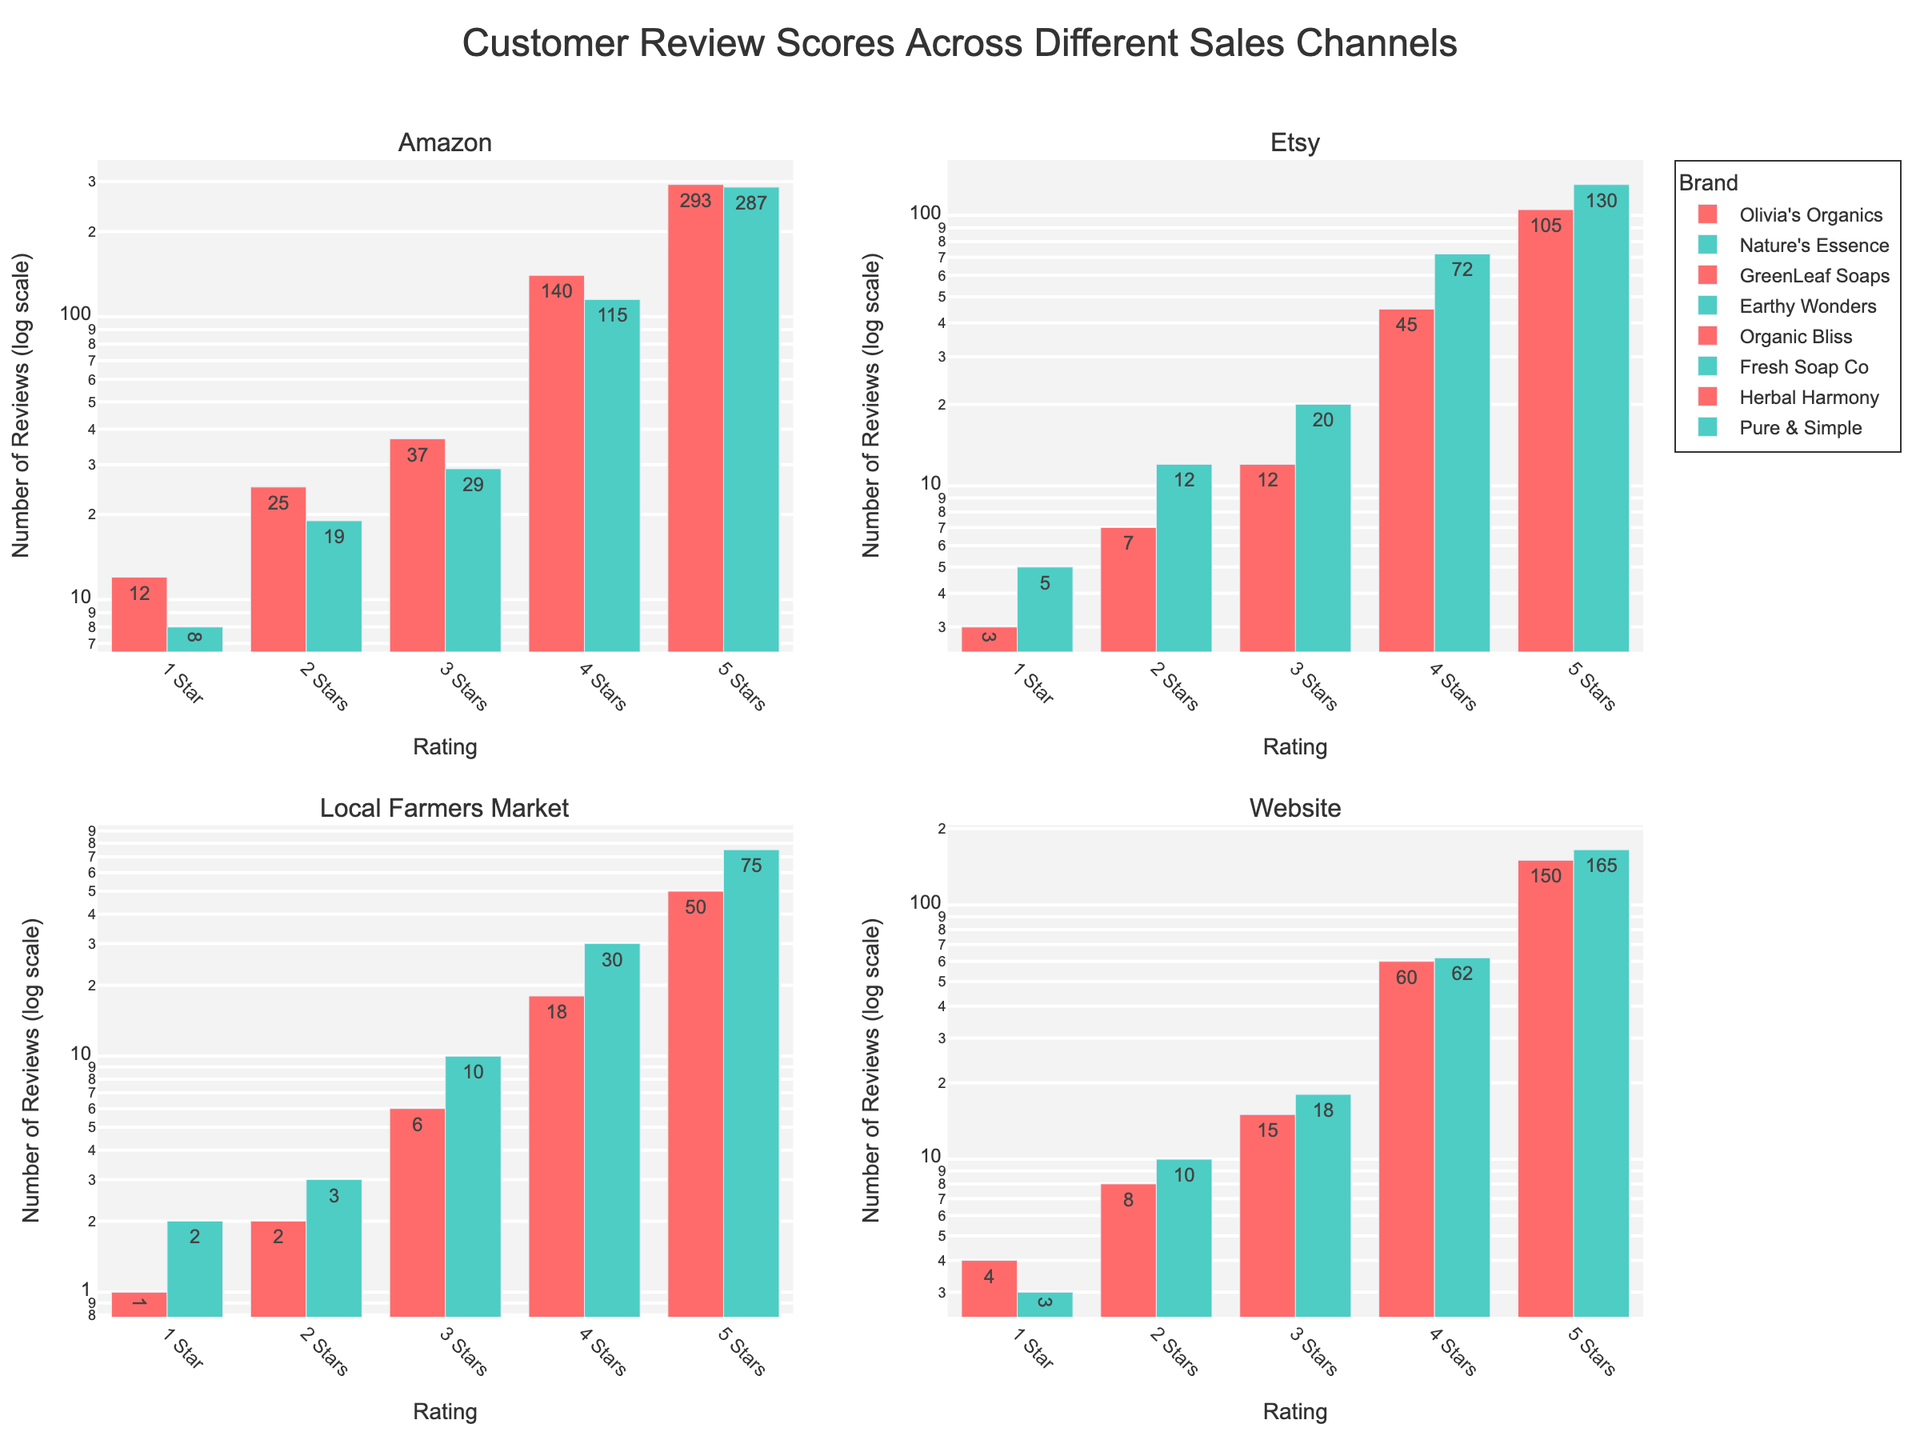How many brands are displayed in each subplot? Count the number of different brands in each subplot for Amazon, Etsy, Farmers Market, and Website.
Answer: 2 brands each Which sales channel received the highest number of 5-star reviews for any brand? Compare the lengths of the bars representing 5-star reviews across all brands in each sales channel. The highest bar is for Olivia's Organics on Amazon.
Answer: Amazon How do the total reviews for GreenLeaf Soaps and Earthy Wonders on Etsy compare? Sum the reviews for each star rating for both brands and compare: GreenLeaf Soaps = 172; Earthy Wonders = 239.
Answer: Earthy Wonders has more What is the total number of 2-star reviews for brands sold at the local farmers market? Add the 2-star reviews for Organic Bliss and Fresh Soap Co: 2 + 3.
Answer: 5 Which brand on the website has a higher proportion of 5-star reviews? Calculate the proportion of 5-star reviews by dividing the 5-star count by the total reviews for each brand: Herbal Harmony = 150/237, Pure & Simple = 165/258.
Answer: Pure & Simple How many more 5-star reviews does Olivia's Organics on Amazon have compared to Fresh Soap Co at the farmers market? Subtract the 5-star reviews for Fresh Soap Co from Olivia's Organics: 293 - 75.
Answer: 218 Which channel shows the most balanced distribution of reviews across all star ratings? Visually inspect the evenness of bar lengths across star ratings in each subplot: Website – both brands show good balance.
Answer: Website In which sales channel do all brands show the least number of 1-star reviews? Compare the height of 1-star review bars across all subplots and find the minimum: Local Farmers Market.
Answer: Local Farmers Market What is the total number of reviews for Nature's Essence on Amazon? Add up the reviews across all star ratings for Nature's Essence: 8 + 19 + 29 + 115 + 287.
Answer: 458 On which sales channel does the brand with the lowest 3-star reviews operate? Identify the shortest 3-star review bar: Organic Bliss on Local Farmers Market.
Answer: Local Farmers Market 